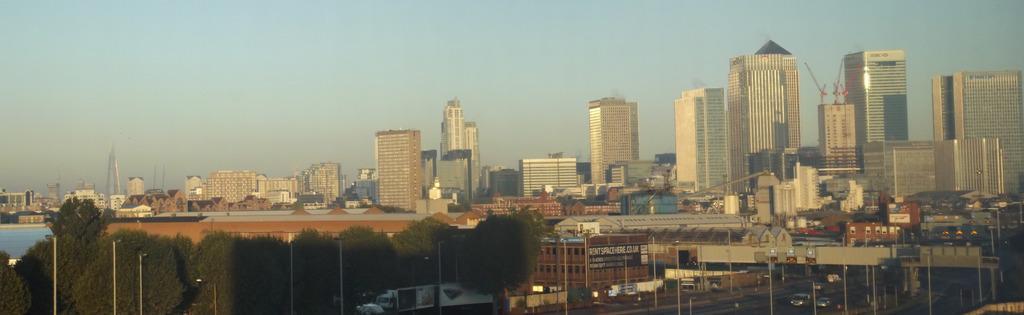In one or two sentences, can you explain what this image depicts? In this picture there are poles, vehicles on the road, trees, buildings and there is water. 